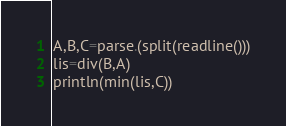<code> <loc_0><loc_0><loc_500><loc_500><_Julia_>A,B,C=parse.(split(readline()))
lis=div(B,A)
println(min(lis,C))</code> 